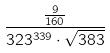Convert formula to latex. <formula><loc_0><loc_0><loc_500><loc_500>\frac { \frac { 9 } { 1 6 0 } } { 3 2 3 ^ { 3 3 9 } \cdot \sqrt { 3 8 3 } }</formula> 